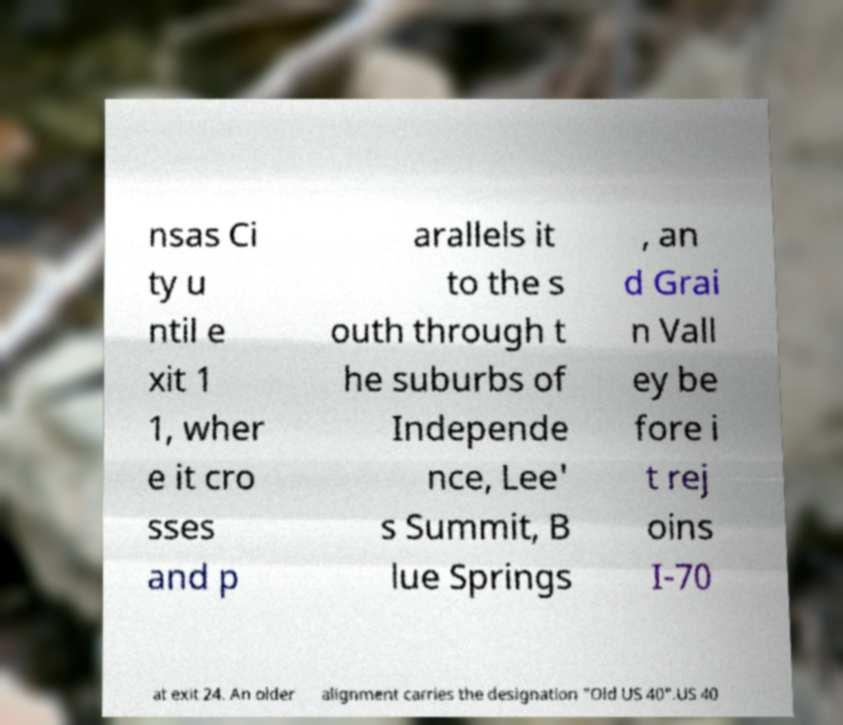Could you extract and type out the text from this image? nsas Ci ty u ntil e xit 1 1, wher e it cro sses and p arallels it to the s outh through t he suburbs of Independe nce, Lee' s Summit, B lue Springs , an d Grai n Vall ey be fore i t rej oins I-70 at exit 24. An older alignment carries the designation "Old US 40".US 40 